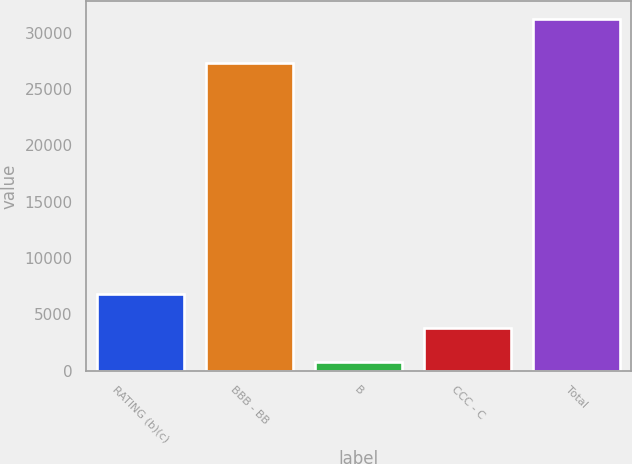Convert chart. <chart><loc_0><loc_0><loc_500><loc_500><bar_chart><fcel>RATING (b)(c)<fcel>BBB - BB<fcel>B<fcel>CCC - C<fcel>Total<nl><fcel>6840<fcel>27321<fcel>740<fcel>3790<fcel>31240<nl></chart> 